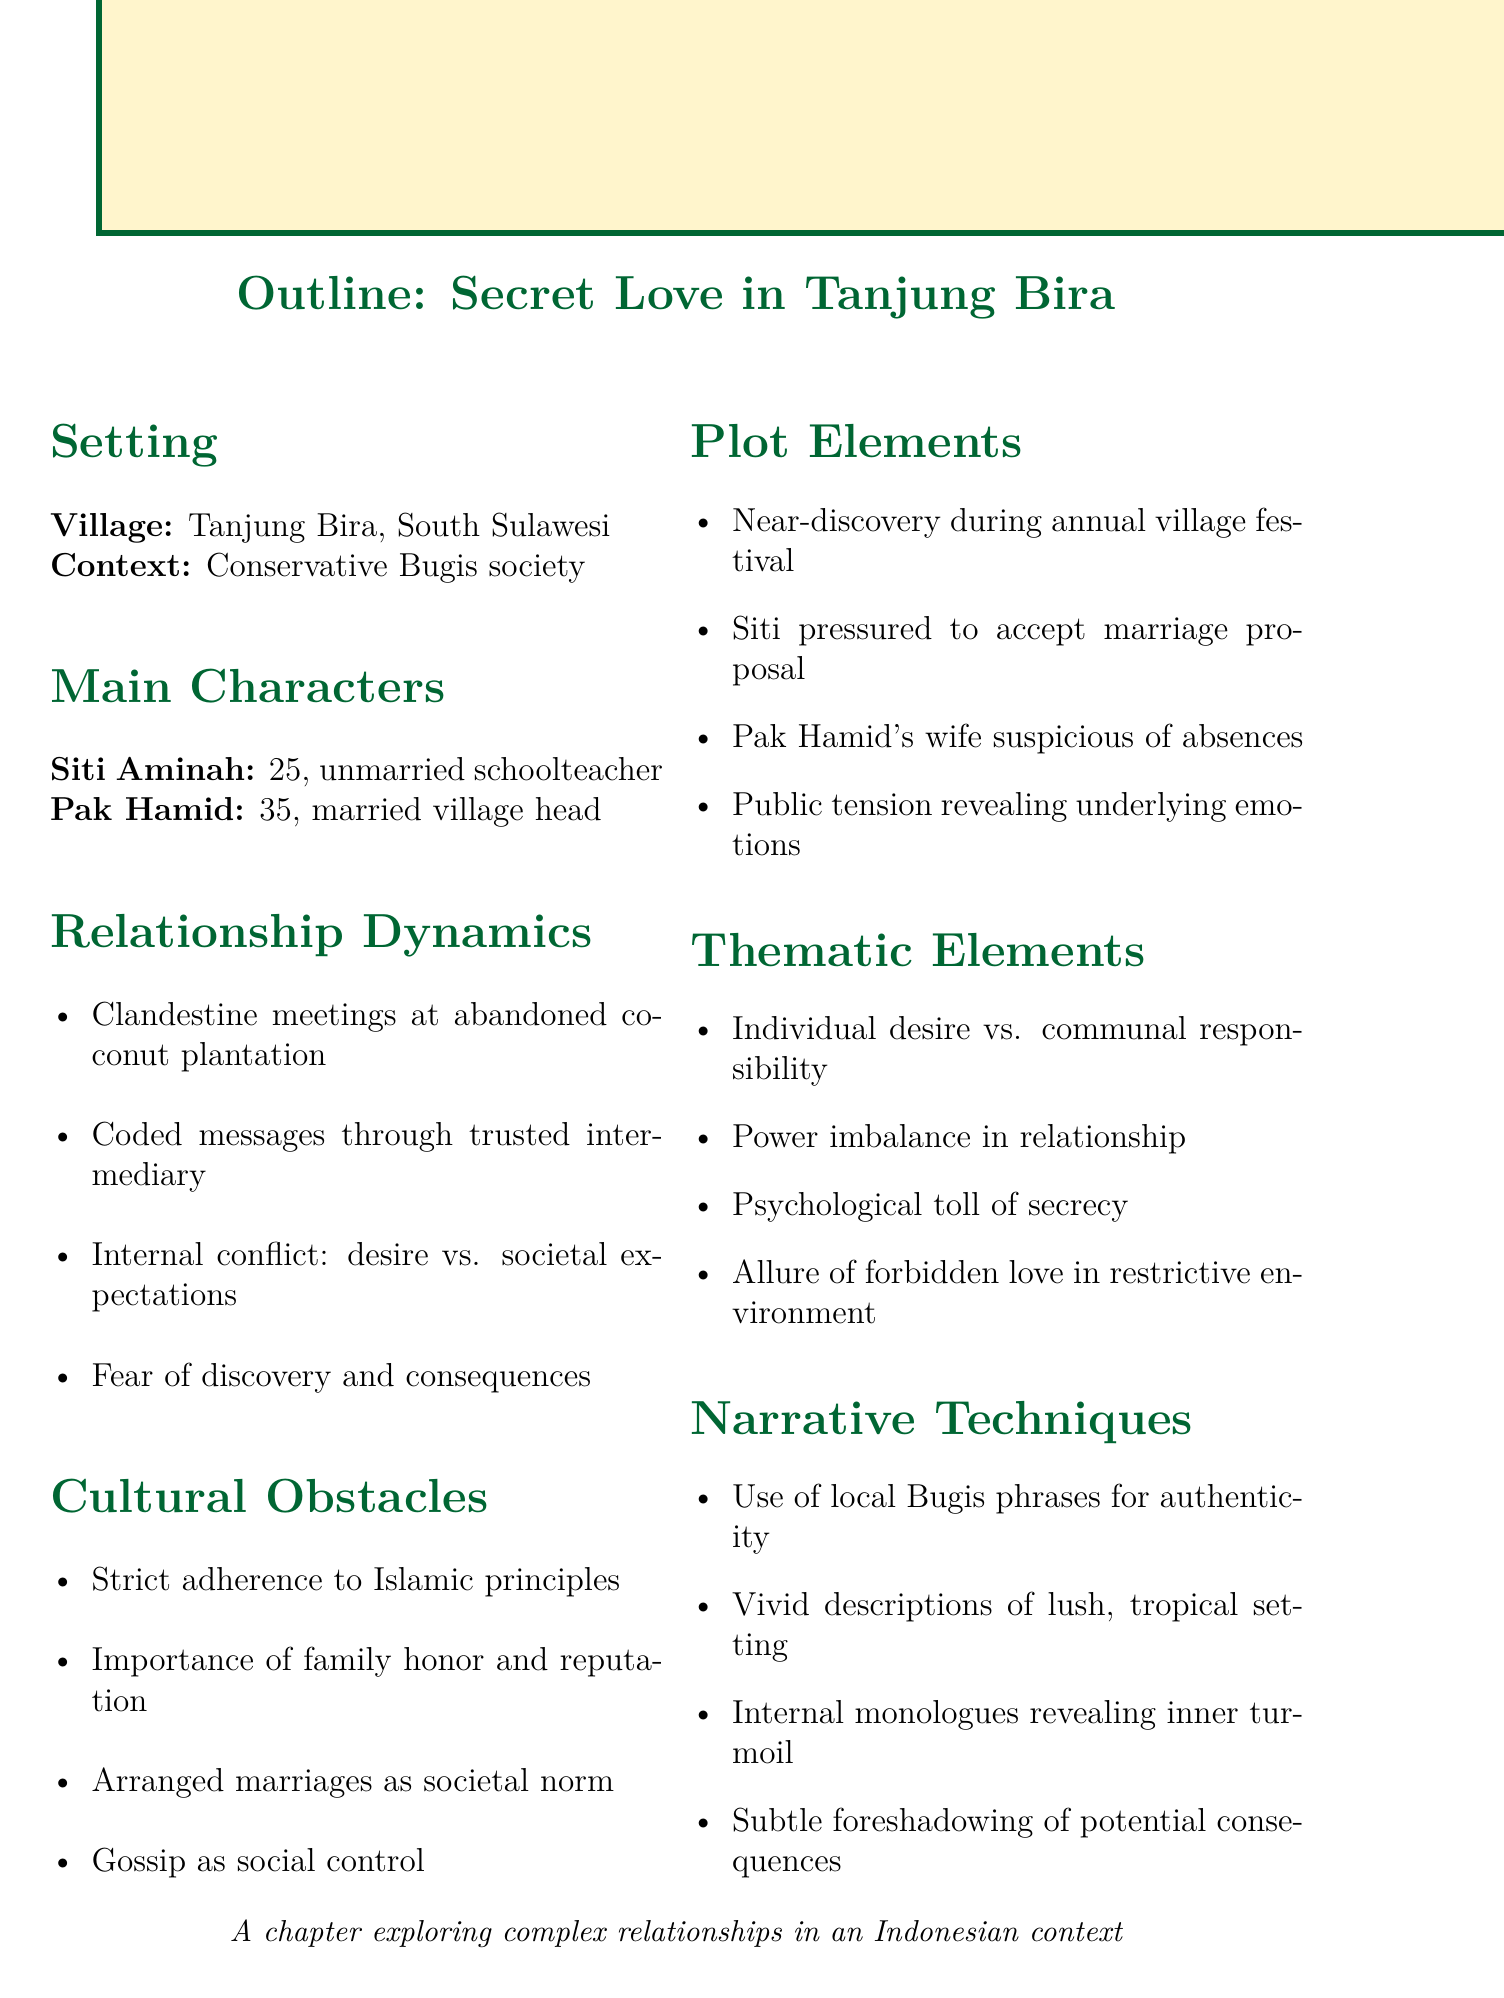What is the name of the village? The document explicitly states that the village is Tanjung Bira.
Answer: Tanjung Bira How old is Siti Aminah? The document mentions that Siti Aminah is 25 years old.
Answer: 25 What is Pak Hamid's occupation? The outline describes Pak Hamid as the village head.
Answer: village head What cultural obstacles are mentioned? The document lists several cultural obstacles including adherence to Islamic principles and arranged marriages.
Answer: Strict adherence to Islamic principles What is the significance of the coconut plantation? The outline indicates that the abandoned coconut plantation is the location for clandestine meetings.
Answer: Clandestine meetings What internal conflict does Siti Aminah face? The document describes her internal conflict as being between desire and societal expectations.
Answer: desire vs. societal expectations During what event is there a near-discovery? The outline specifies that the near-discovery happens during the annual village festival.
Answer: annual village festival What narrative technique is used to enhance authenticity? The document states that the use of local Bugis phrases adds authenticity to the narrative.
Answer: local Bugis phrases What underlying theme is explored regarding the relationship dynamics? The document mentions the power imbalance in their relationship as a theme.
Answer: Power imbalance in relationship 